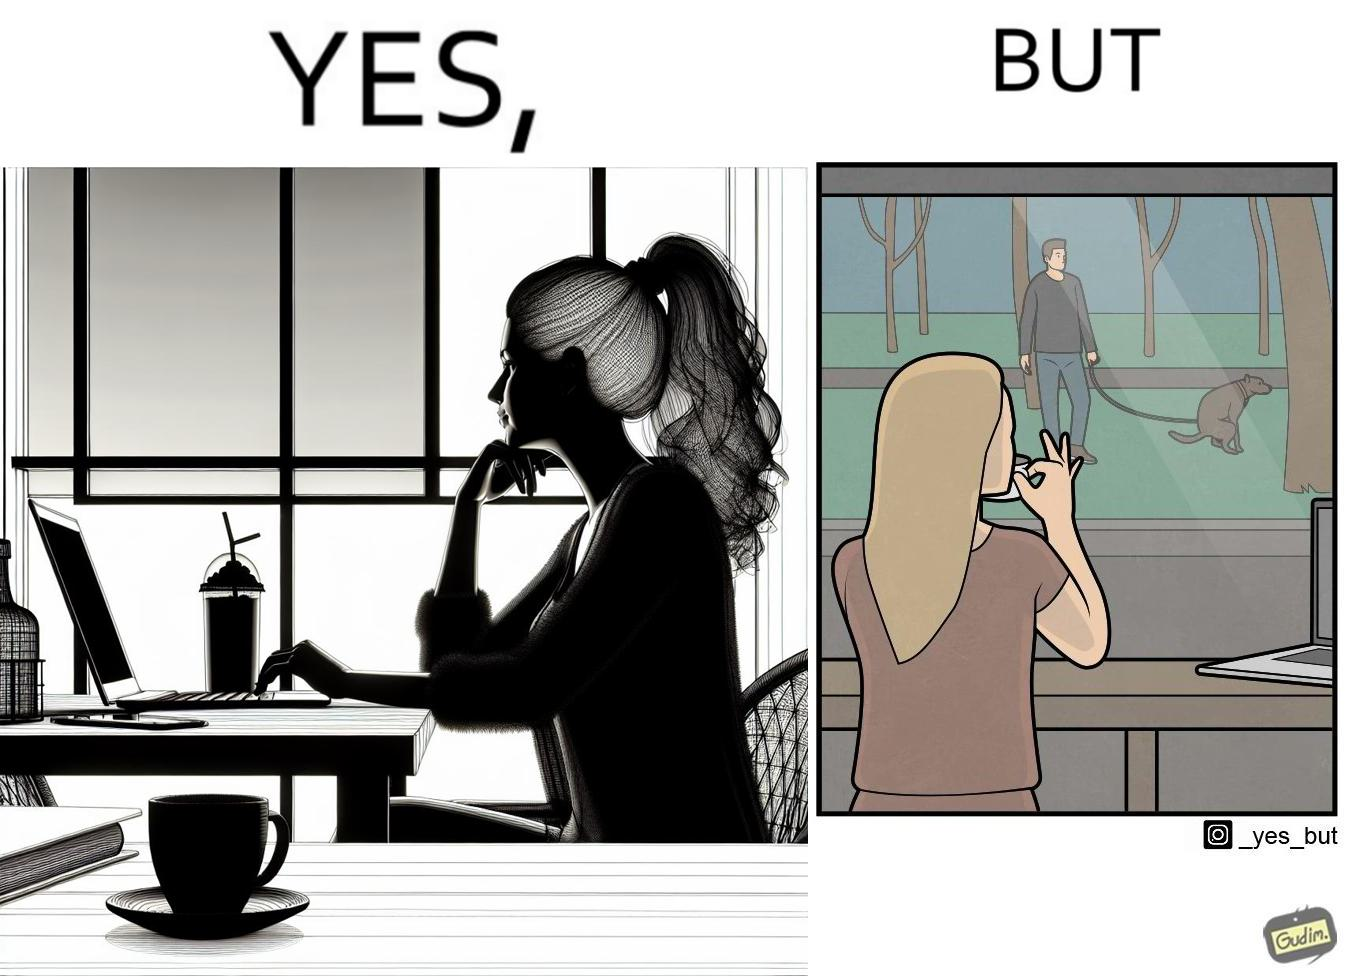Describe the content of this image. The image is ironic, because in the first image the woman is seen as enjoying the view but in the second image the same woman is seen as looking at a pooping dog 